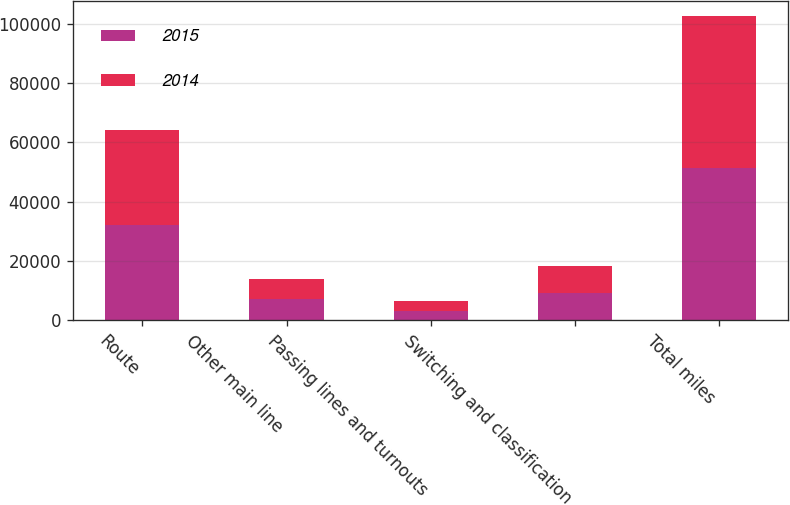Convert chart to OTSL. <chart><loc_0><loc_0><loc_500><loc_500><stacked_bar_chart><ecel><fcel>Route<fcel>Other main line<fcel>Passing lines and turnouts<fcel>Switching and classification<fcel>Total miles<nl><fcel>2015<fcel>32084<fcel>7012<fcel>3235<fcel>9108<fcel>51439<nl><fcel>2014<fcel>31974<fcel>6943<fcel>3197<fcel>9058<fcel>51172<nl></chart> 